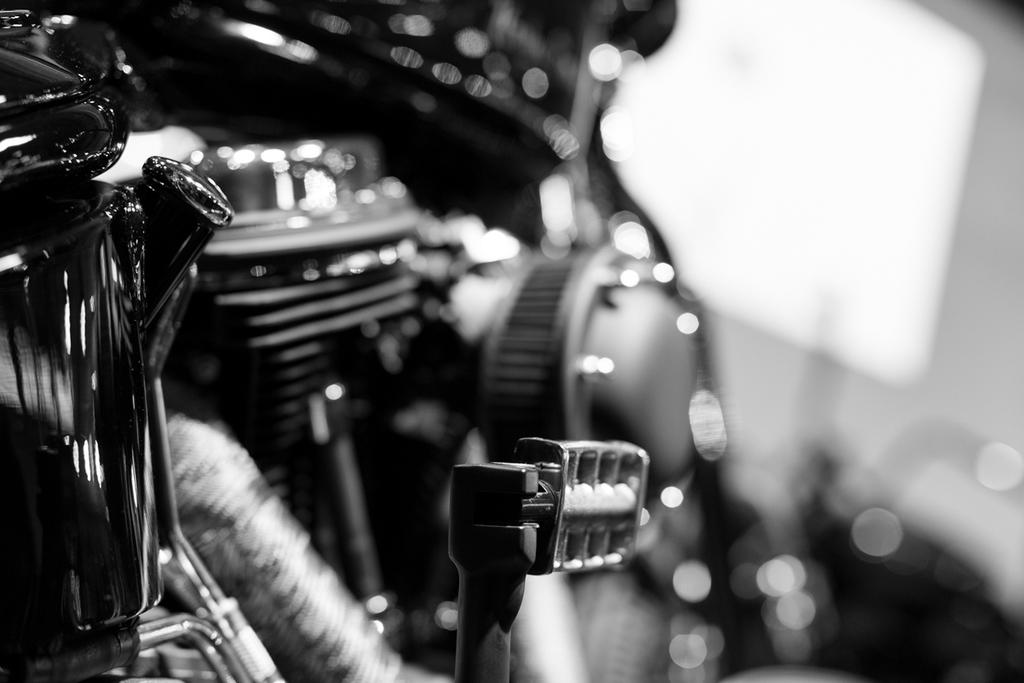What is the main subject of the image? There is a vehicle in the image. How much of the vehicle can be seen in the image? The vehicle is partially visible. What color is the vehicle in the image? The vehicle is black in color. How many cattle are grazing near the vehicle in the image? There are no cattle present in the image; it only features a partially visible black vehicle. Are there any fairies flying around the vehicle in the image? There are no fairies present in the image; it only features a partially visible black vehicle. 